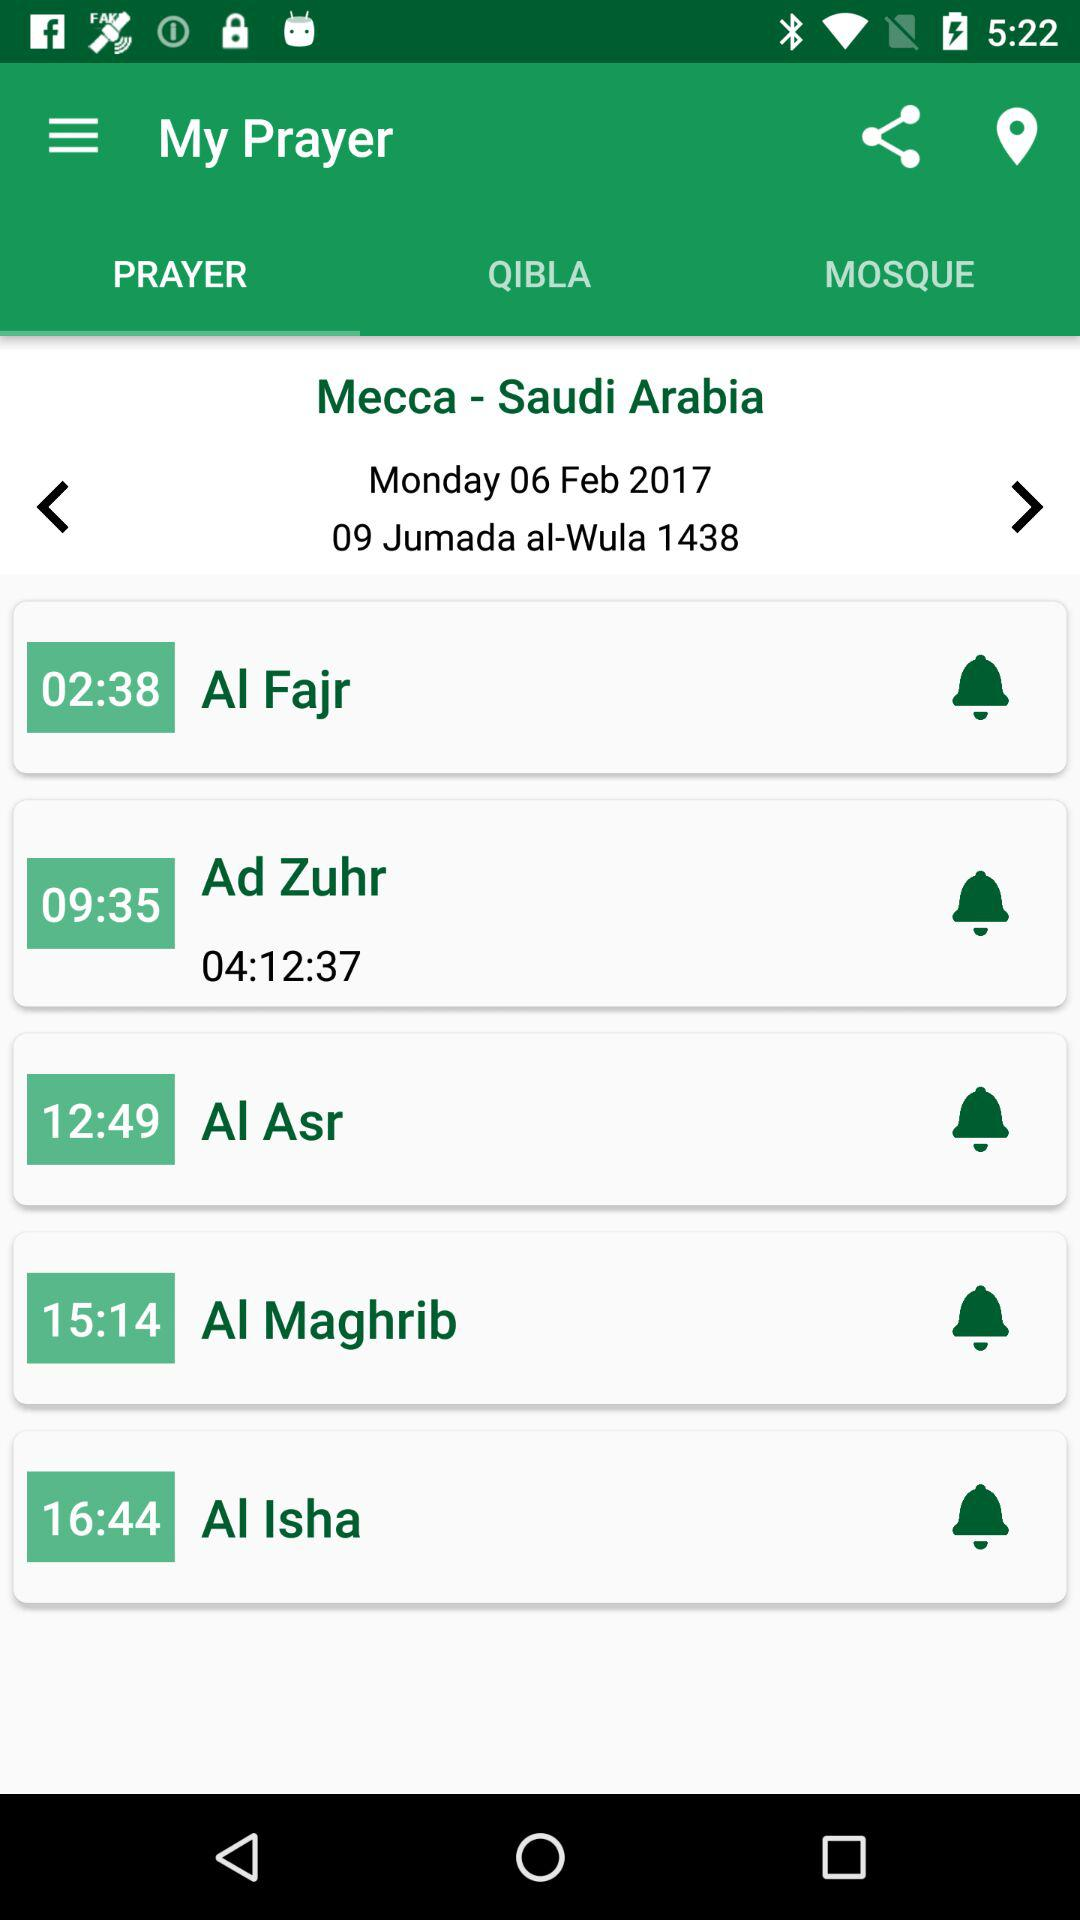What is the time of the "Al Fajr" prayer? The time is 02:38. 